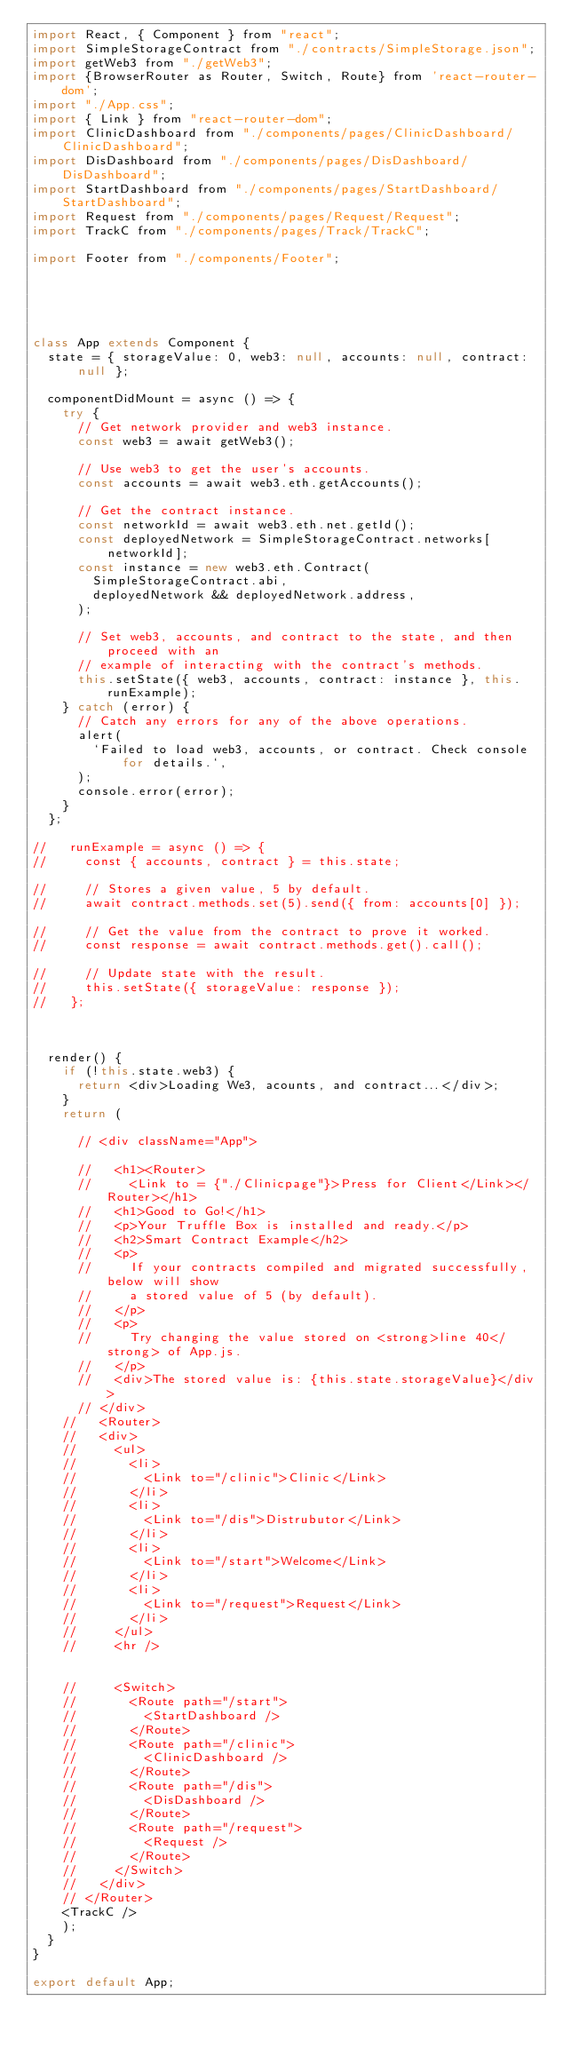<code> <loc_0><loc_0><loc_500><loc_500><_JavaScript_>import React, { Component } from "react";
import SimpleStorageContract from "./contracts/SimpleStorage.json";
import getWeb3 from "./getWeb3";
import {BrowserRouter as Router, Switch, Route} from 'react-router-dom';
import "./App.css";
import { Link } from "react-router-dom";
import ClinicDashboard from "./components/pages/ClinicDashboard/ClinicDashboard";
import DisDashboard from "./components/pages/DisDashboard/DisDashboard";
import StartDashboard from "./components/pages/StartDashboard/StartDashboard";
import Request from "./components/pages/Request/Request";
import TrackC from "./components/pages/Track/TrackC";

import Footer from "./components/Footer";





class App extends Component {
  state = { storageValue: 0, web3: null, accounts: null, contract: null };

  componentDidMount = async () => {
    try {
      // Get network provider and web3 instance.
      const web3 = await getWeb3();

      // Use web3 to get the user's accounts.
      const accounts = await web3.eth.getAccounts();

      // Get the contract instance.
      const networkId = await web3.eth.net.getId();
      const deployedNetwork = SimpleStorageContract.networks[networkId];
      const instance = new web3.eth.Contract(
        SimpleStorageContract.abi,
        deployedNetwork && deployedNetwork.address,
      );

      // Set web3, accounts, and contract to the state, and then proceed with an
      // example of interacting with the contract's methods.
      this.setState({ web3, accounts, contract: instance }, this.runExample);
    } catch (error) {
      // Catch any errors for any of the above operations.
      alert(
        `Failed to load web3, accounts, or contract. Check console for details.`,
      );
      console.error(error);
    }
  };

//   runExample = async () => {
//     const { accounts, contract } = this.state;

//     // Stores a given value, 5 by default.
//     await contract.methods.set(5).send({ from: accounts[0] });

//     // Get the value from the contract to prove it worked.
//     const response = await contract.methods.get().call();

//     // Update state with the result.
//     this.setState({ storageValue: response });
//   };

  

  render() {
    if (!this.state.web3) {
      return <div>Loading We3, acounts, and contract...</div>;
    }
    return (
      
      // <div className="App">
        
      //   <h1><Router>
      //     <Link to = {"./Clinicpage"}>Press for Client</Link></Router></h1>
      //   <h1>Good to Go!</h1>
      //   <p>Your Truffle Box is installed and ready.</p>
      //   <h2>Smart Contract Example</h2>
      //   <p>
      //     If your contracts compiled and migrated successfully, below will show
      //     a stored value of 5 (by default).
      //   </p>
      //   <p>
      //     Try changing the value stored on <strong>line 40</strong> of App.js.
      //   </p>
      //   <div>The stored value is: {this.state.storageValue}</div>
      // </div>
    //   <Router>
    //   <div>
    //     <ul>
    //       <li>
    //         <Link to="/clinic">Clinic</Link>
    //       </li>
    //       <li>
    //         <Link to="/dis">Distrubutor</Link>
    //       </li>
    //       <li>
    //         <Link to="/start">Welcome</Link>
    //       </li>
    //       <li>
    //         <Link to="/request">Request</Link>
    //       </li>
    //     </ul>
    //     <hr />

      
    //     <Switch>
    //       <Route path="/start">
    //         <StartDashboard />
    //       </Route>
    //       <Route path="/clinic">
    //         <ClinicDashboard />
    //       </Route>
    //       <Route path="/dis">
    //         <DisDashboard />
    //       </Route>
    //       <Route path="/request">
    //         <Request />
    //       </Route>
    //     </Switch>
    //   </div>
    // </Router>
    <TrackC />
    );
  }
}

export default App;
</code> 